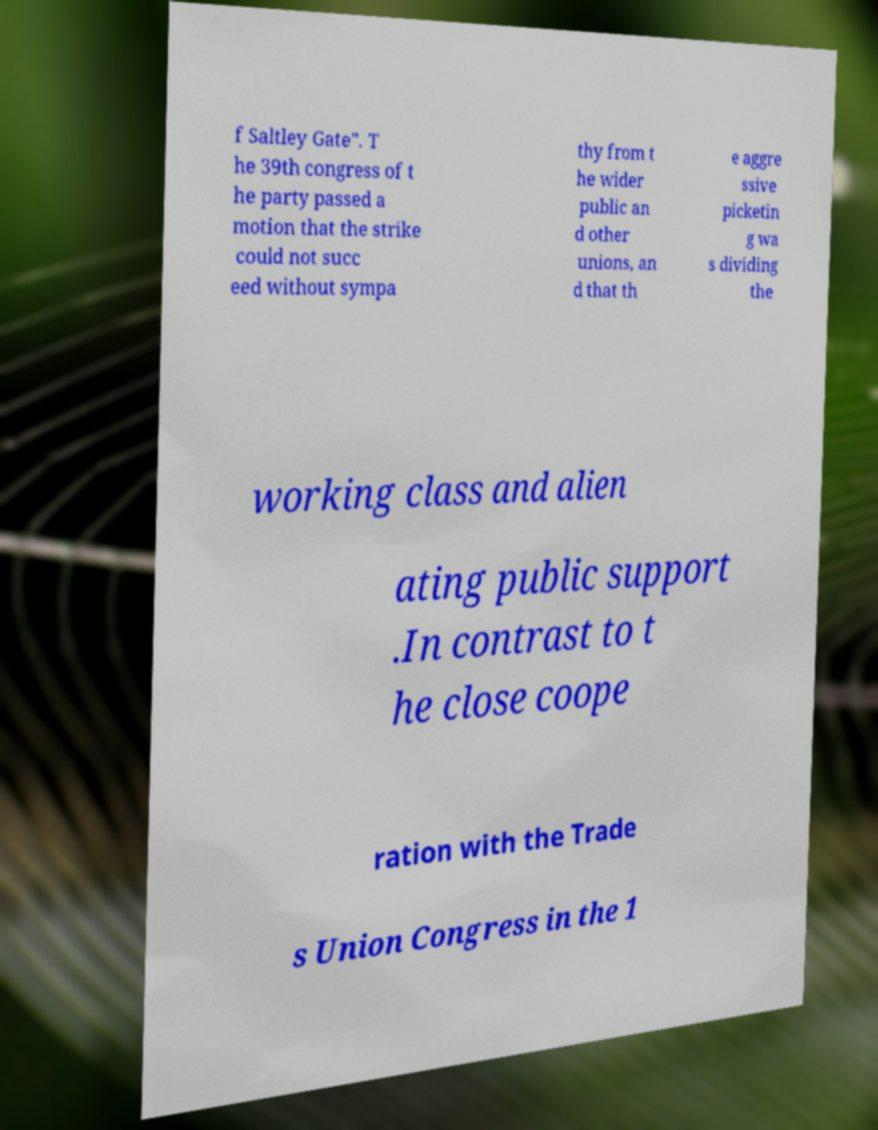There's text embedded in this image that I need extracted. Can you transcribe it verbatim? f Saltley Gate". T he 39th congress of t he party passed a motion that the strike could not succ eed without sympa thy from t he wider public an d other unions, an d that th e aggre ssive picketin g wa s dividing the working class and alien ating public support .In contrast to t he close coope ration with the Trade s Union Congress in the 1 